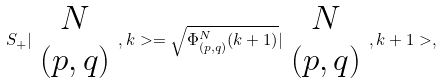Convert formula to latex. <formula><loc_0><loc_0><loc_500><loc_500>S _ { + } | \begin{array} { c } N \\ ( p , q ) \end{array} , k > = \sqrt { \Phi _ { ( p , q ) } ^ { N } ( k + 1 ) } | \begin{array} { c } N \\ ( p , q ) \end{array} , k + 1 > ,</formula> 